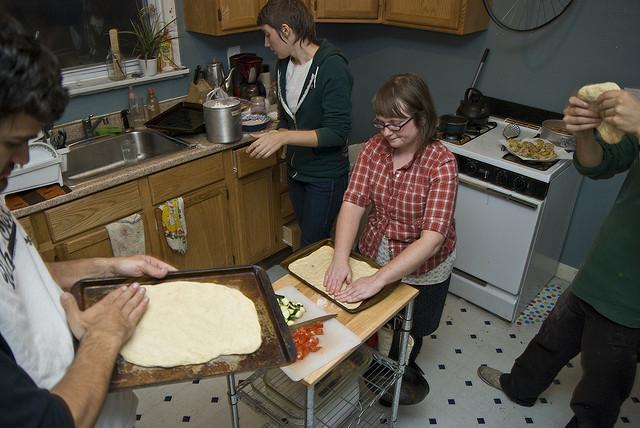Is this a busy kitchen?
Short answer required. Yes. What are they making?
Be succinct. Pizza. What is being fried?
Quick response, please. Pizza. What is the person carrying?
Be succinct. Dough. What is written on the girl's shirt?
Be succinct. Nothing. What kind of floor is it?
Concise answer only. Tile. Is it day or night time outside?
Give a very brief answer. Night. 